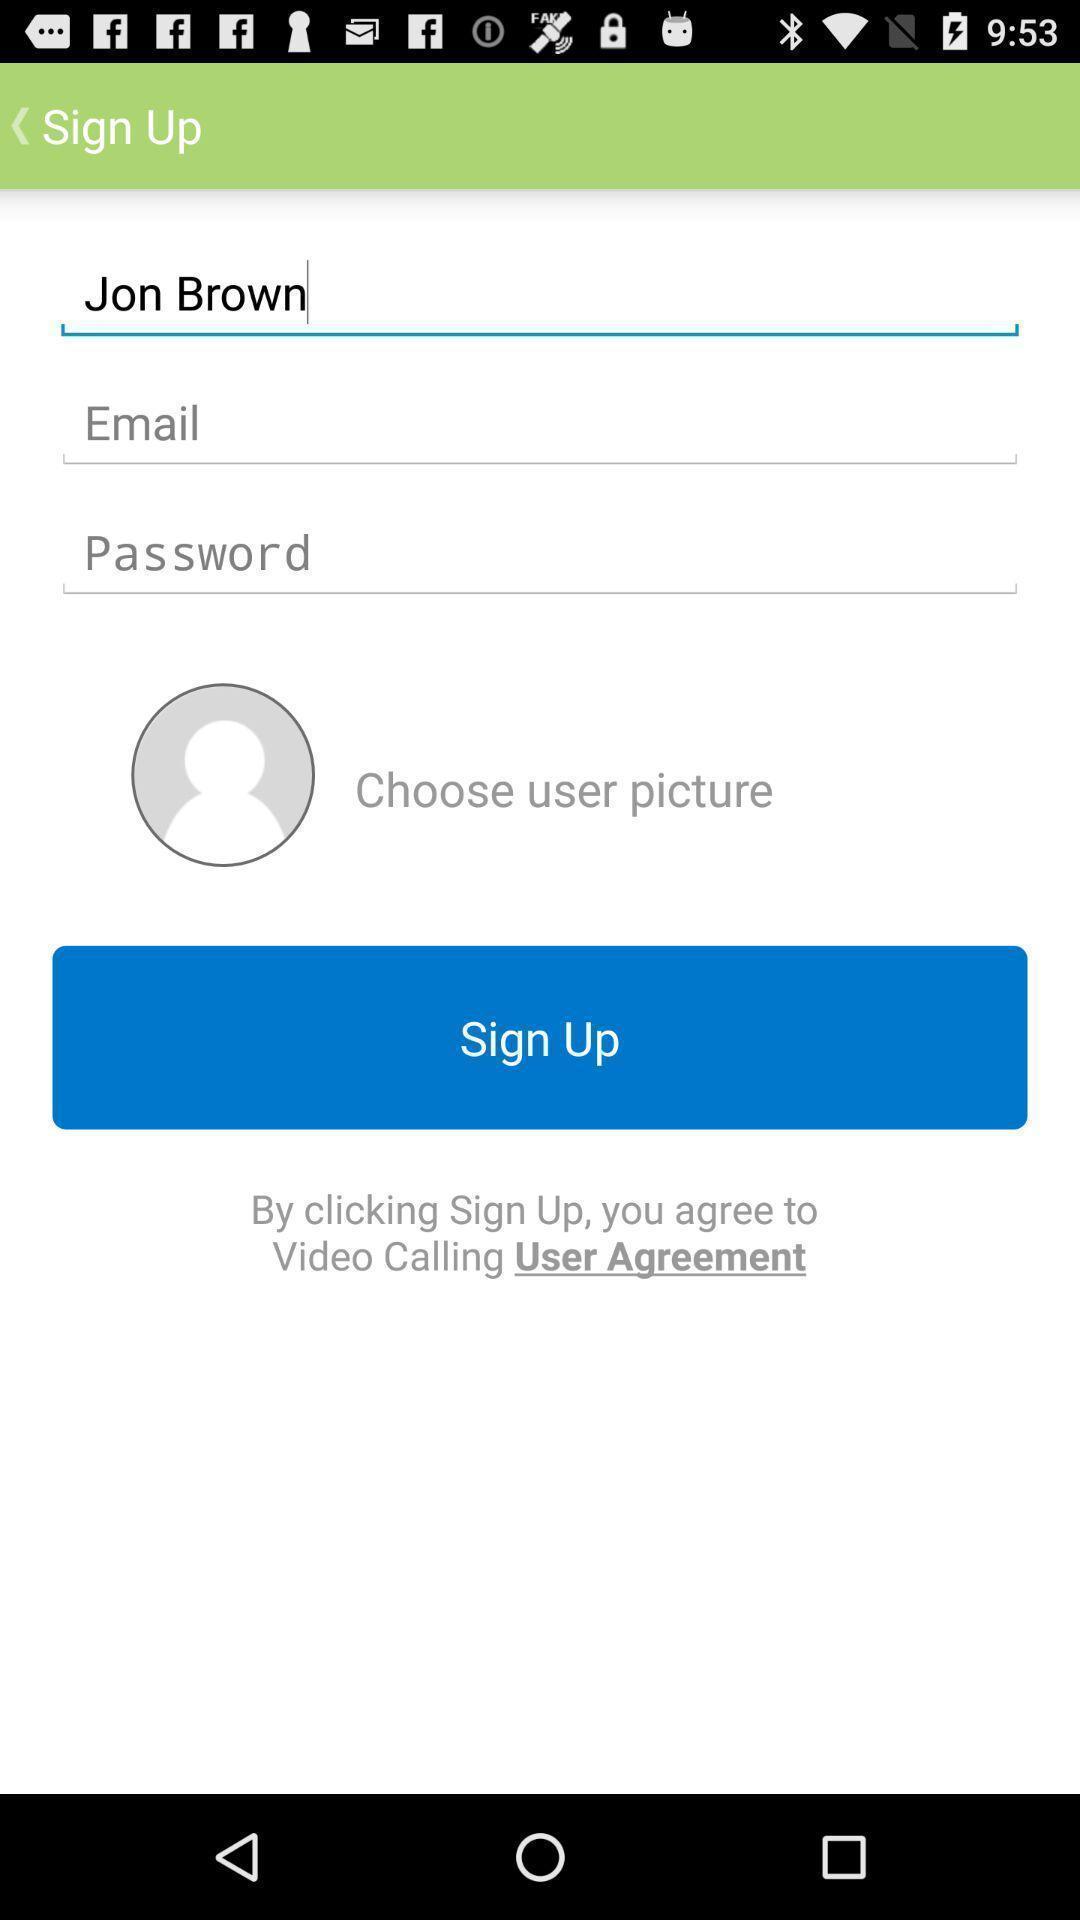Give me a narrative description of this picture. Signup page for a video calling application. 